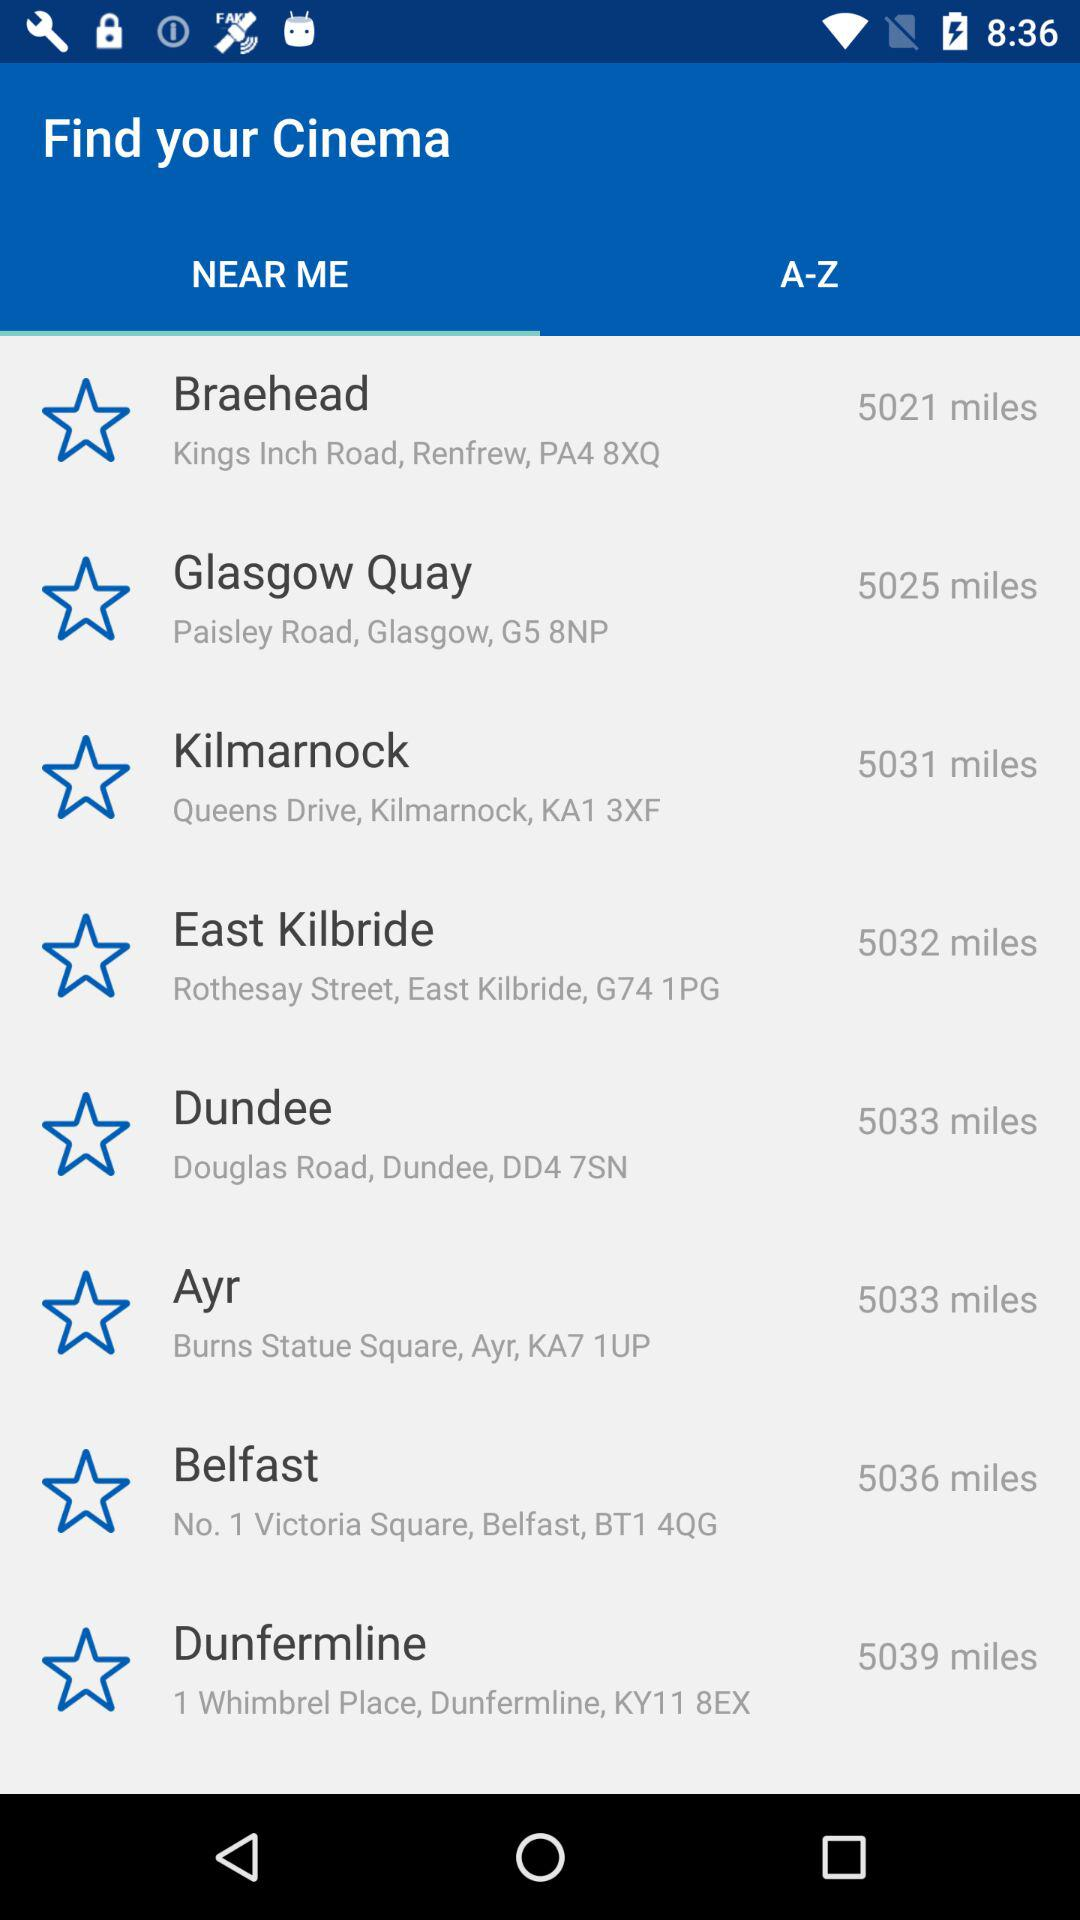Which tab is selected? The selected tab is "NEAR ME". 